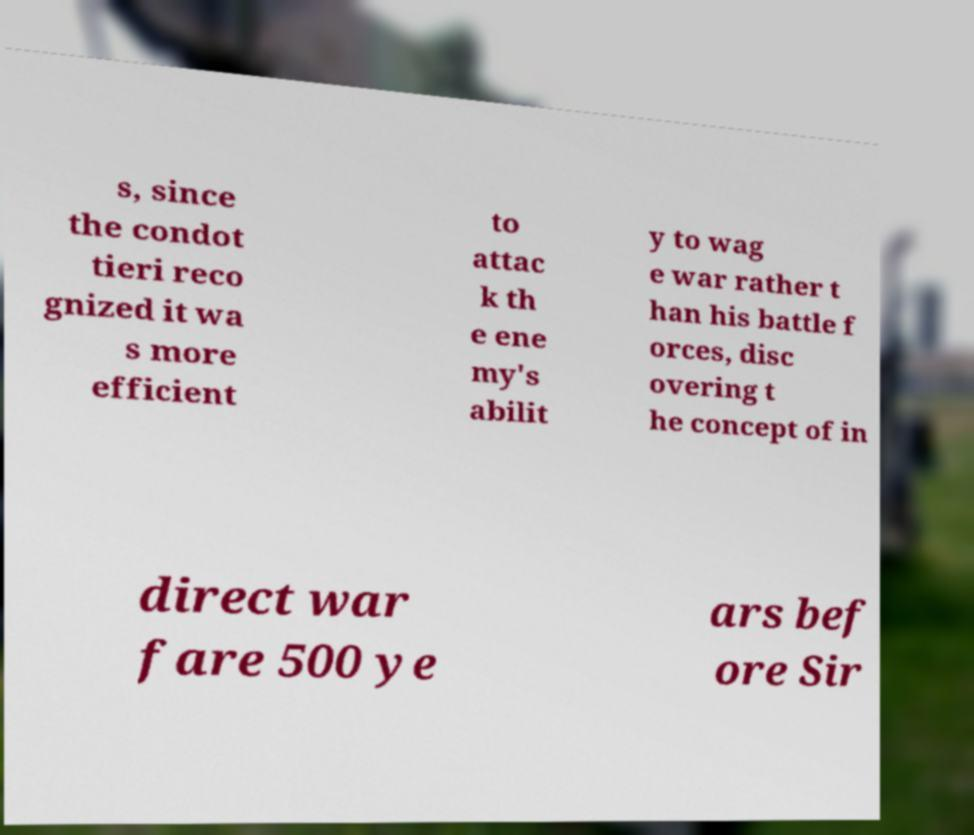For documentation purposes, I need the text within this image transcribed. Could you provide that? s, since the condot tieri reco gnized it wa s more efficient to attac k th e ene my's abilit y to wag e war rather t han his battle f orces, disc overing t he concept of in direct war fare 500 ye ars bef ore Sir 